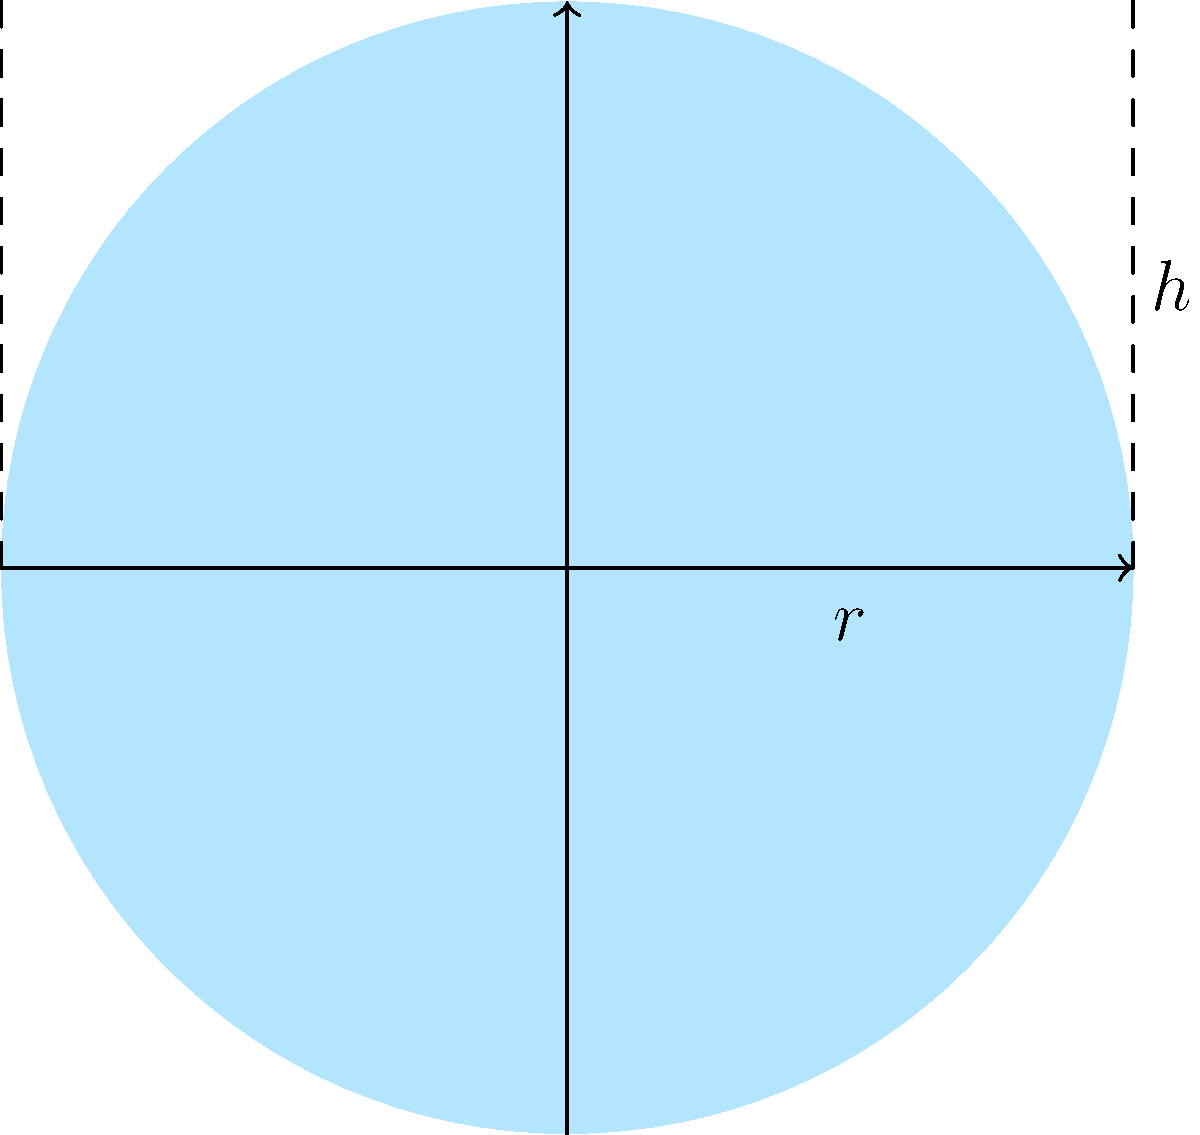As a veterinarian specializing in water quality and animal health, you need to calculate the surface area of a cylindrical water storage tank for aquatic animals. The tank has a radius of 2.5 meters and a height of 6 meters. What is the total surface area of the tank, including the top and bottom circular surfaces? To calculate the surface area of a cylindrical tank, we need to consider three parts:
1. The circular top surface
2. The circular bottom surface
3. The curved lateral surface

Let's break it down step-by-step:

1. Area of circular top and bottom:
   $A_{circle} = \pi r^2$
   $A_{circle} = \pi (2.5\text{ m})^2 = 19.63\text{ m}^2$
   We have two circular surfaces, so: $2 \times 19.63\text{ m}^2 = 39.26\text{ m}^2$

2. Area of curved lateral surface:
   $A_{lateral} = 2\pi rh$
   $A_{lateral} = 2\pi (2.5\text{ m})(6\text{ m}) = 94.25\text{ m}^2$

3. Total surface area:
   $A_{total} = 2A_{circle} + A_{lateral}$
   $A_{total} = 39.26\text{ m}^2 + 94.25\text{ m}^2 = 133.51\text{ m}^2$

Therefore, the total surface area of the cylindrical water storage tank is approximately 133.51 square meters.
Answer: $133.51\text{ m}^2$ 